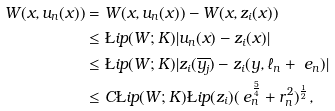Convert formula to latex. <formula><loc_0><loc_0><loc_500><loc_500>W ( x , u _ { n } ( x ) ) & = W ( x , u _ { n } ( x ) ) - W ( x , z _ { i } ( x ) ) \\ & \leq \L i p ( W ; K ) | u _ { n } ( x ) - z _ { i } ( x ) | \\ & \leq \L i p ( W ; K ) | z _ { i } ( \overline { y _ { j } } ) - z _ { i } ( y , \ell _ { n } + \ e _ { n } ) | \\ & \leq C \L i p ( W ; K ) \L i p ( z _ { i } ) ( \ e _ { n } ^ { \frac { 5 } { 4 } } + r _ { n } ^ { 2 } ) ^ { \frac { 1 } { 2 } } ,</formula> 